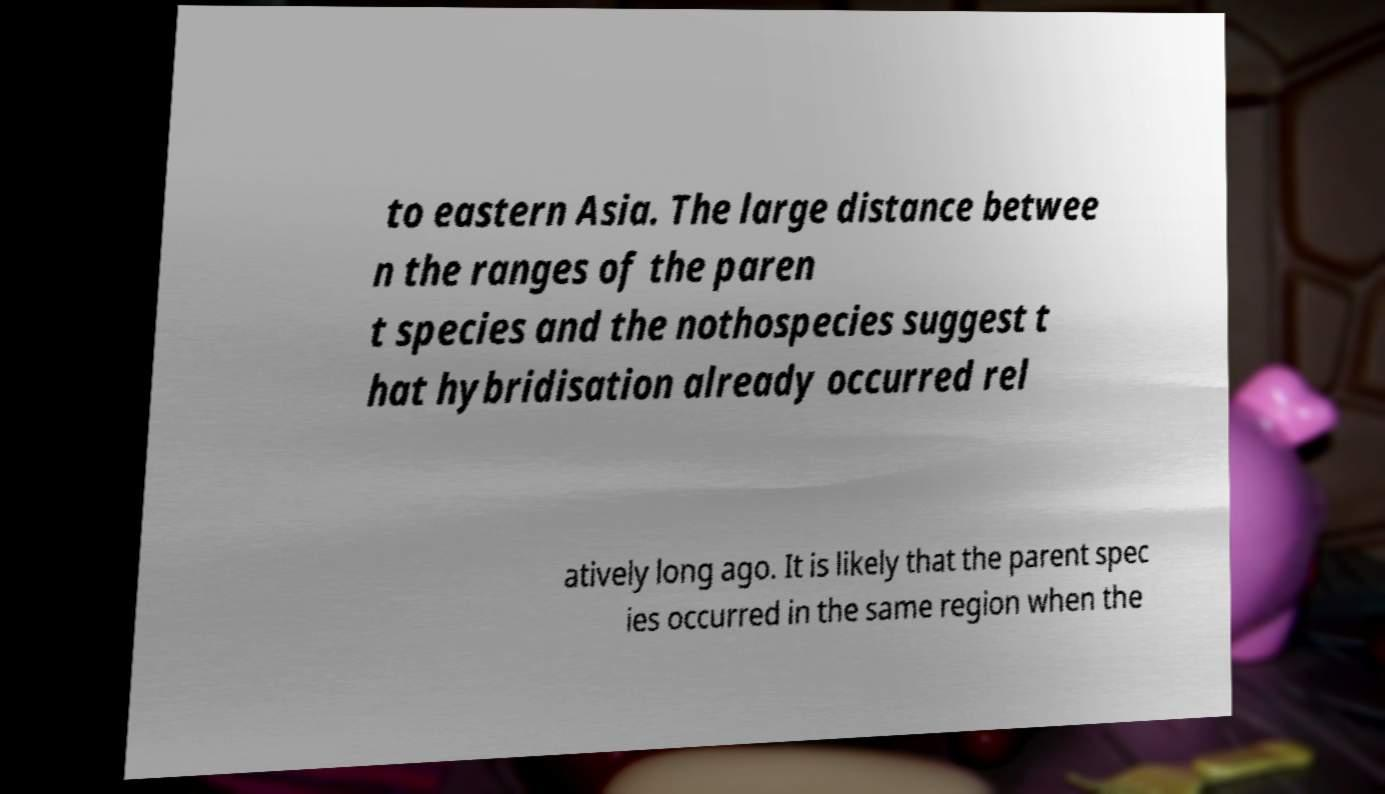I need the written content from this picture converted into text. Can you do that? to eastern Asia. The large distance betwee n the ranges of the paren t species and the nothospecies suggest t hat hybridisation already occurred rel atively long ago. It is likely that the parent spec ies occurred in the same region when the 